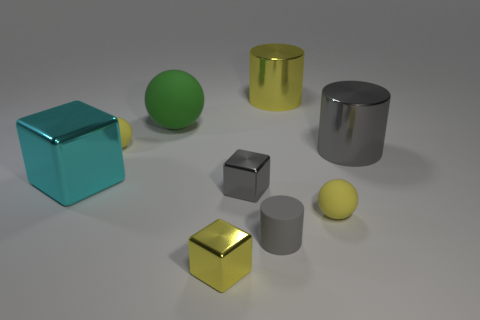There is a tiny cylinder; is its color the same as the large metallic cylinder that is in front of the yellow cylinder?
Offer a very short reply. Yes. Does the rubber sphere in front of the large cube have the same size as the gray thing that is behind the cyan object?
Ensure brevity in your answer.  No. What is the shape of the small metal object that is the same color as the small cylinder?
Offer a terse response. Cube. Are there any other metallic cylinders of the same color as the tiny cylinder?
Your answer should be compact. Yes. Is there a yellow metallic block in front of the object to the right of the yellow matte sphere that is in front of the cyan cube?
Ensure brevity in your answer.  Yes. Are there more large cyan metallic objects that are on the left side of the small cylinder than big green metal cubes?
Ensure brevity in your answer.  Yes. There is a matte thing right of the small cylinder; does it have the same shape as the gray rubber object?
Provide a short and direct response. No. What number of objects are either gray rubber cylinders or matte things that are to the right of the big yellow cylinder?
Give a very brief answer. 2. There is a rubber ball that is both to the left of the large yellow metallic thing and in front of the large matte thing; what is its size?
Your answer should be compact. Small. Are there more small gray things that are to the left of the tiny gray rubber cylinder than green rubber spheres behind the large green matte sphere?
Ensure brevity in your answer.  Yes. 